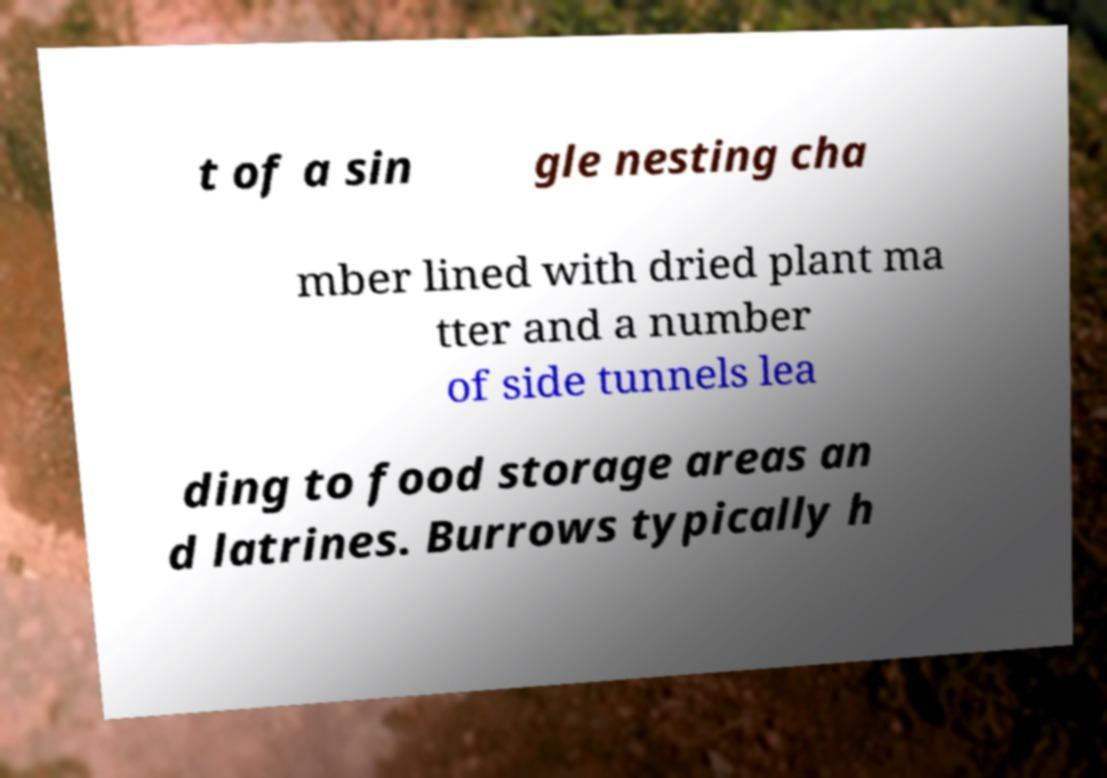Can you accurately transcribe the text from the provided image for me? t of a sin gle nesting cha mber lined with dried plant ma tter and a number of side tunnels lea ding to food storage areas an d latrines. Burrows typically h 